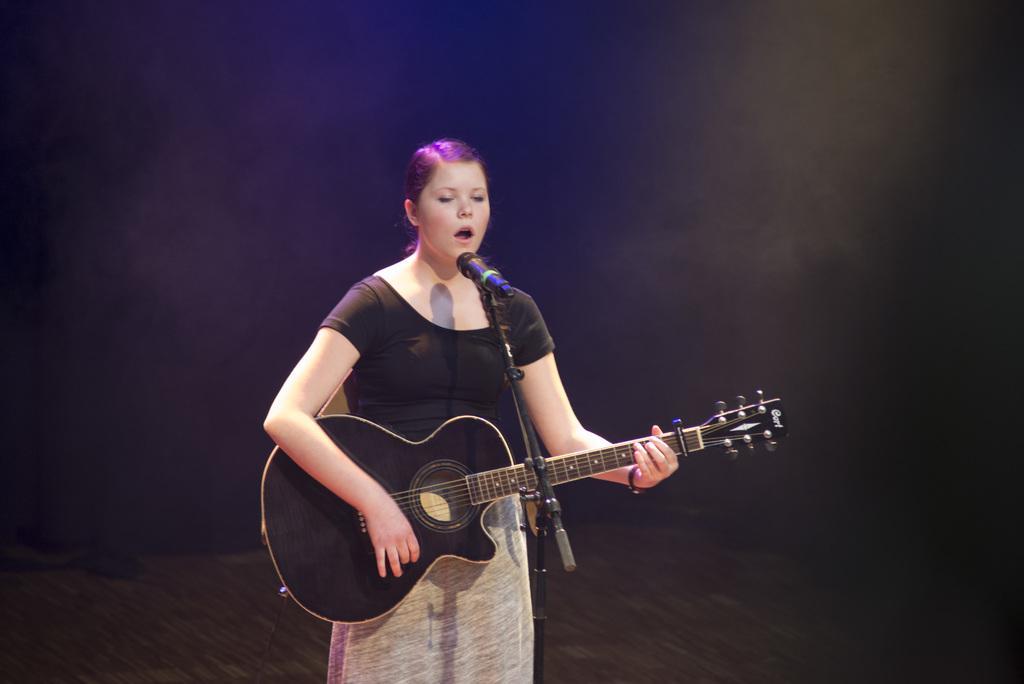Please provide a concise description of this image. There is a woman standing in the center. She is playing a guitar and singing on a microphone. 